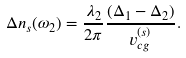Convert formula to latex. <formula><loc_0><loc_0><loc_500><loc_500>\Delta n _ { s } ( \omega _ { 2 } ) = \frac { \lambda _ { 2 } } { 2 \pi } \frac { ( \Delta _ { 1 } - \Delta _ { 2 } ) } { v ^ { ( s ) } _ { c g } } .</formula> 